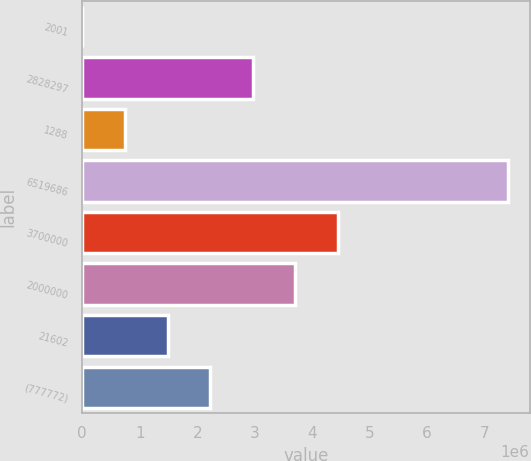Convert chart to OTSL. <chart><loc_0><loc_0><loc_500><loc_500><bar_chart><fcel>2001<fcel>2828297<fcel>1288<fcel>6519686<fcel>3700000<fcel>2000000<fcel>21602<fcel>(777772)<nl><fcel>2005<fcel>2.96529e+06<fcel>742826<fcel>7.41021e+06<fcel>4.44693e+06<fcel>3.70611e+06<fcel>1.48365e+06<fcel>2.22447e+06<nl></chart> 